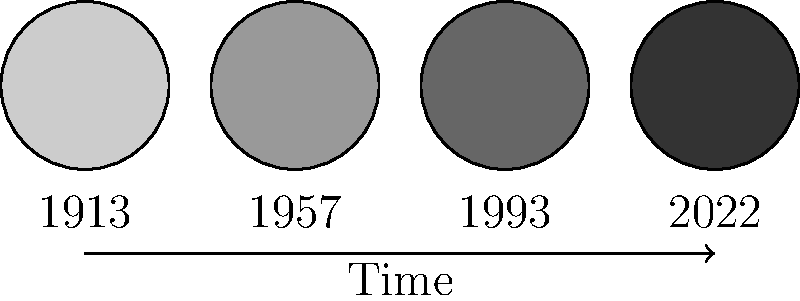Based on the evolution of U.S. Cremonese's logo shown in the graphic, which year marks the most significant change in the logo's design, transitioning from a lighter to a darker shade? To answer this question, let's analyze the logo evolution step-by-step:

1. The graphic shows four circular logos representing U.S. Cremonese's logo evolution from 1913 to 2022.

2. Each logo is represented by a circle with a different shade of gray.

3. The logos are arranged chronologically from left to right:
   - 1913: Lightest shade (almost white)
   - 1957: Light gray
   - 1993: Dark gray
   - 2022: Darkest shade (almost black)

4. We need to identify the most significant change in shade from lighter to darker.

5. Comparing the transitions:
   - 1913 to 1957: Small change from very light to light gray
   - 1957 to 1993: Larger change from light gray to dark gray
   - 1993 to 2022: Small change from dark gray to very dark gray

6. The most significant change in shade occurs between 1957 and 1993.

Therefore, 1993 marks the most significant change in the logo's design, transitioning from a lighter to a darker shade.
Answer: 1993 